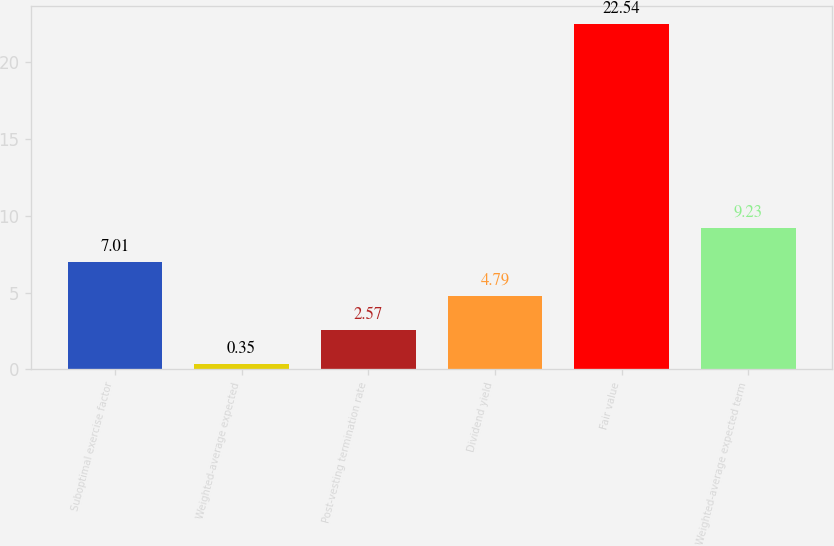Convert chart. <chart><loc_0><loc_0><loc_500><loc_500><bar_chart><fcel>Suboptimal exercise factor<fcel>Weighted-average expected<fcel>Post-vesting termination rate<fcel>Dividend yield<fcel>Fair value<fcel>Weighted-average expected term<nl><fcel>7.01<fcel>0.35<fcel>2.57<fcel>4.79<fcel>22.54<fcel>9.23<nl></chart> 